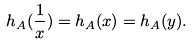Convert formula to latex. <formula><loc_0><loc_0><loc_500><loc_500>h _ { A } ( \frac { 1 } { x } ) = h _ { A } ( x ) = h _ { A } ( y ) .</formula> 